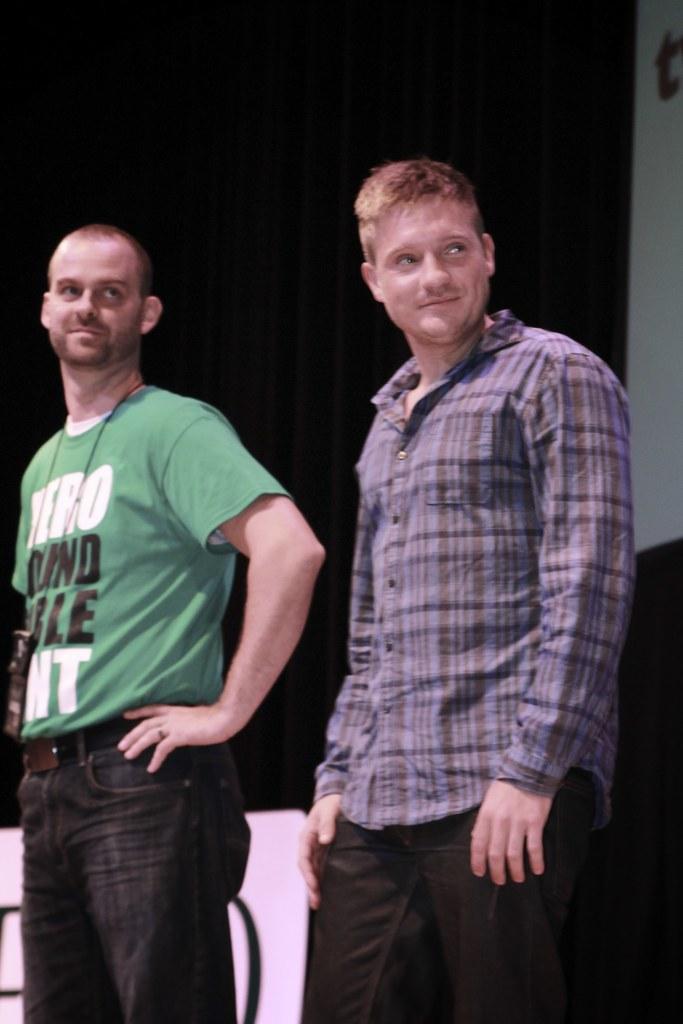Could you give a brief overview of what you see in this image? In the center of the image we can see persons standing on the floor. In the background we can see and advertisement. 